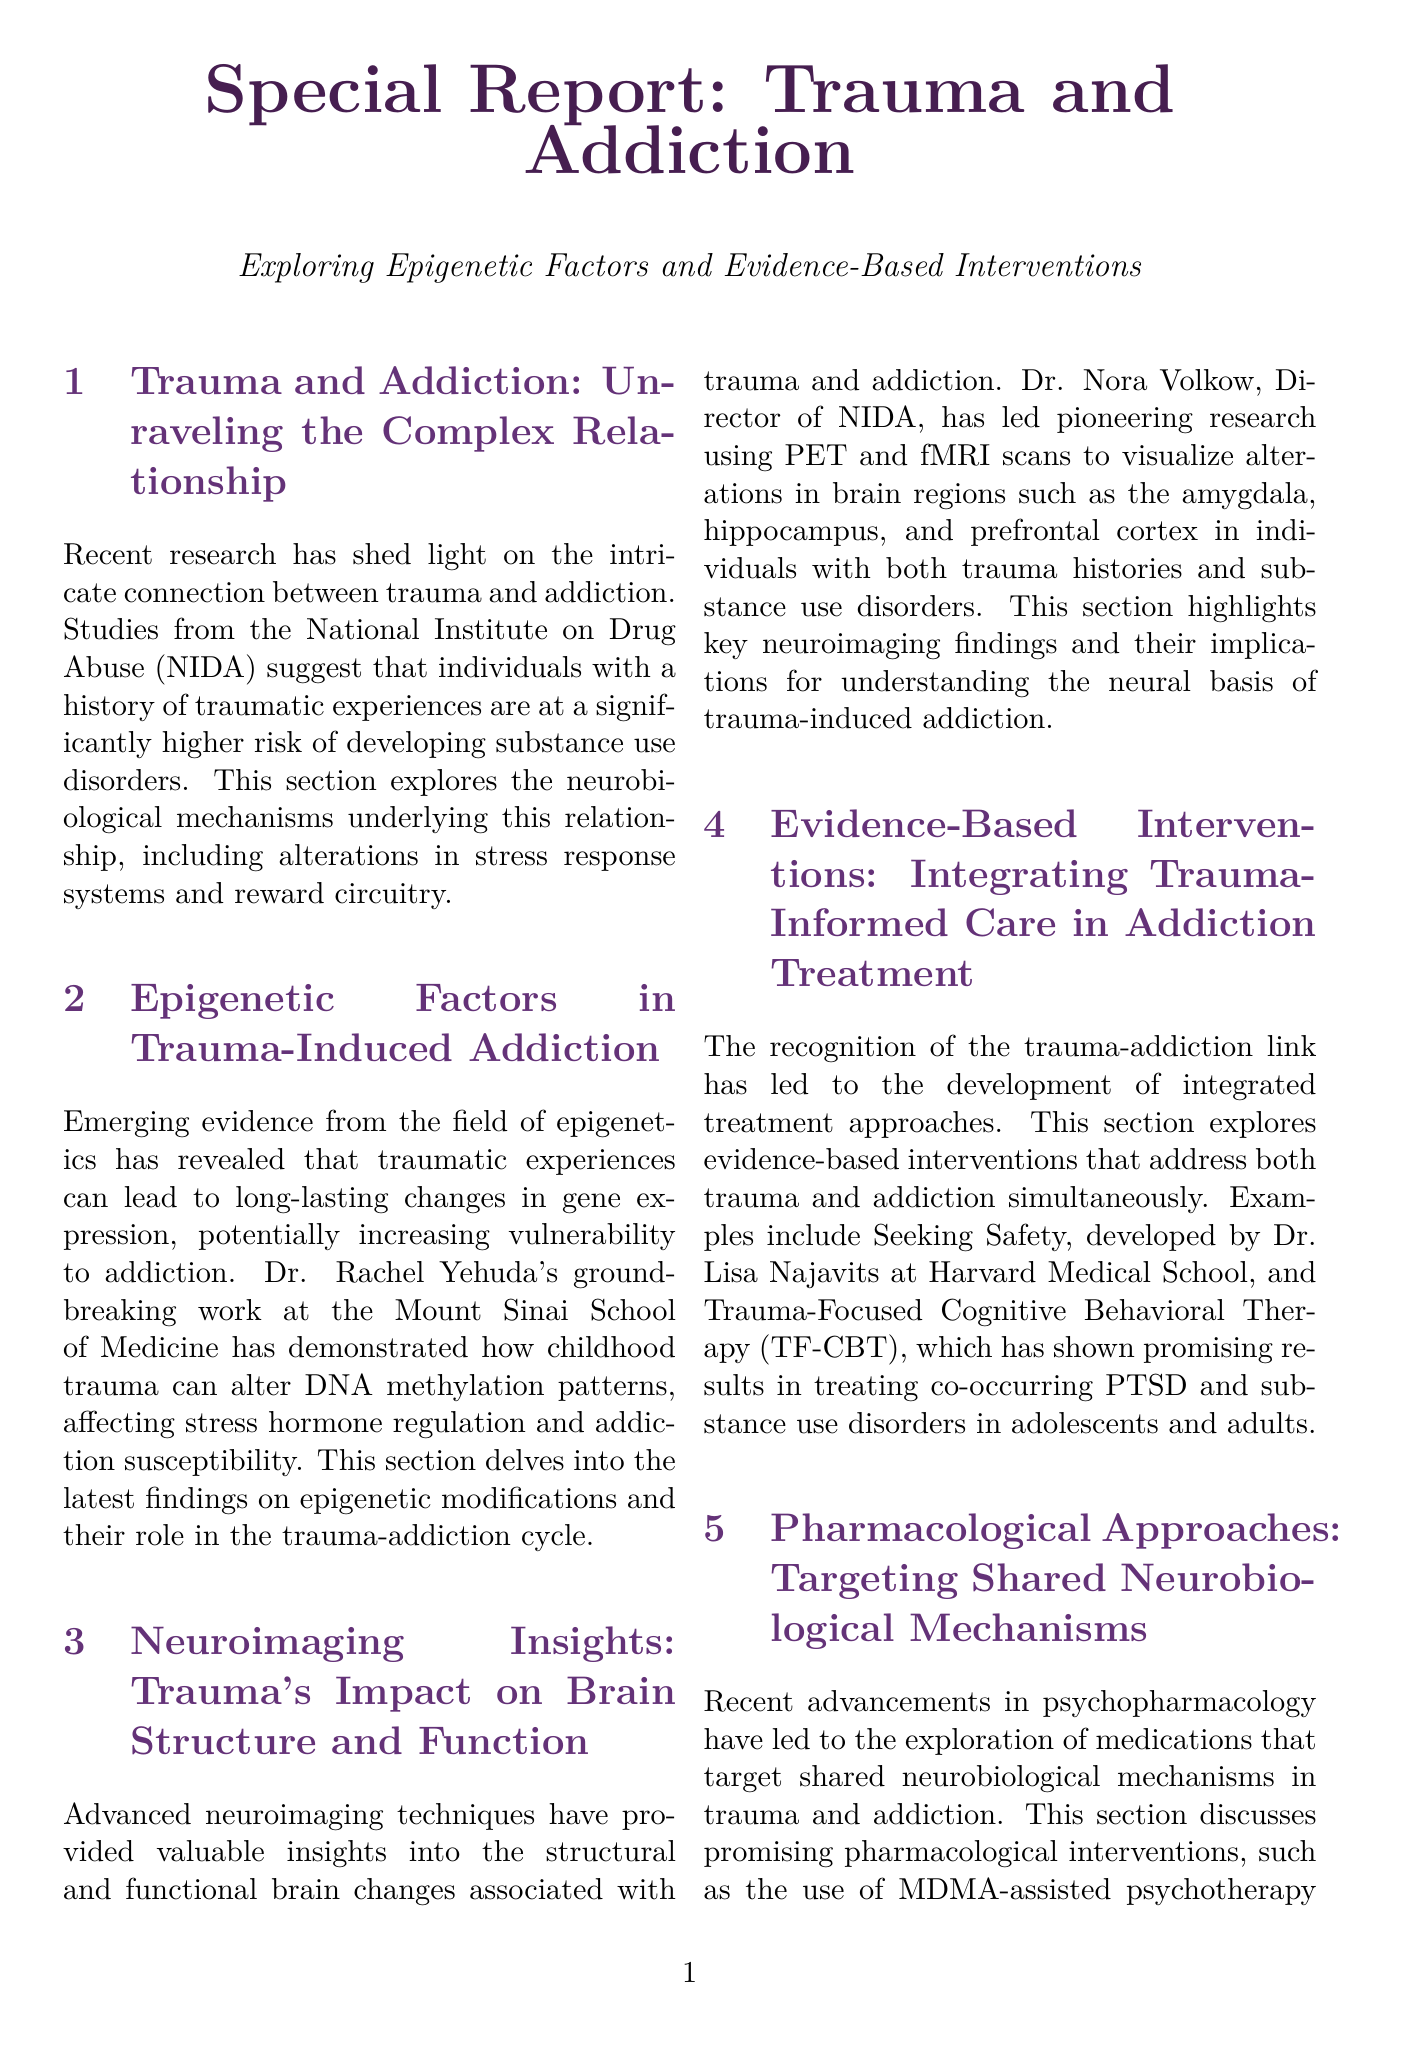What does NIDA stand for? The acronym NIDA refers to the National Institute on Drug Abuse, which is mentioned in the document regarding research on trauma and addiction.
Answer: National Institute on Drug Abuse Who conducted pioneering research using PET and fMRI scans? Dr. Nora Volkow is named in the document as leading the research on neuroimaging techniques related to trauma and addiction.
Answer: Dr. Nora Volkow What kind of therapy was developed by Dr. Lisa Najavits? The document states that Dr. Lisa Najavits developed the intervention called Seeking Safety for treating trauma and addiction.
Answer: Seeking Safety Which neurotransmitter is focused on for pharmacological approaches in the document? The document discusses MDMA-assisted psychotherapy, which targets trauma and addiction through neurotransmitter mechanisms.
Answer: MDMA What type of research is highlighted in the section on future directions? The document emphasizes personalized medicine approaches for developing tailored interventions based on various profiles.
Answer: Personalized medicine What kind of hormone regulation is affected by childhood trauma? The section on epigenetic factors describes how childhood trauma can alter DNA methylation patterns, affecting stress hormone regulation.
Answer: Stress hormone regulation What are two medications mentioned that address trauma symptoms and substance cravings? The document lists prazosin and propranolol as medications showing potential in addressing both issues.
Answer: Prazosin and propranolol Which cognitive therapy is mentioned for treating co-occurring PTSD and substance use disorders? The document references Trauma-Focused Cognitive Behavioral Therapy as a promising intervention for these co-occurring disorders.
Answer: Trauma-Focused Cognitive Behavioral Therapy 